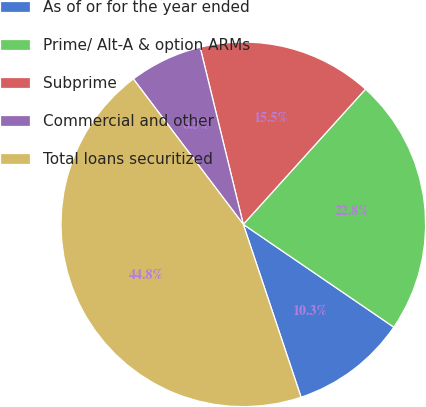Convert chart. <chart><loc_0><loc_0><loc_500><loc_500><pie_chart><fcel>As of or for the year ended<fcel>Prime/ Alt-A & option ARMs<fcel>Subprime<fcel>Commercial and other<fcel>Total loans securitized<nl><fcel>10.33%<fcel>22.84%<fcel>15.5%<fcel>6.5%<fcel>44.83%<nl></chart> 